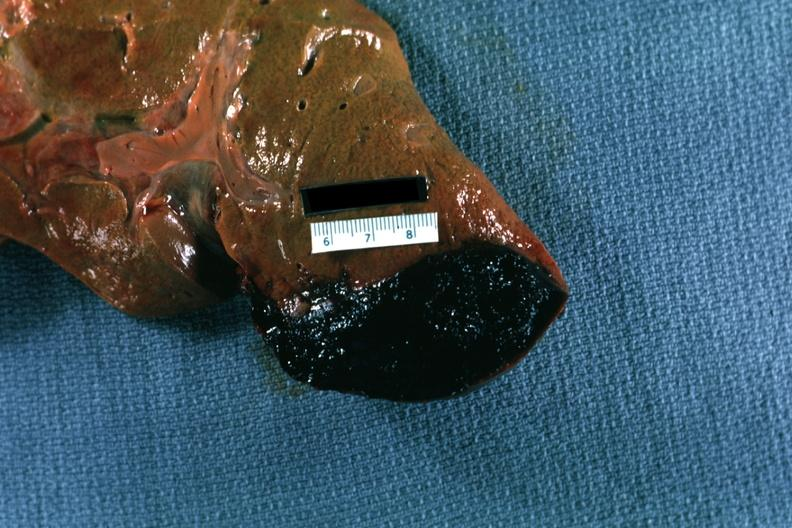does this image show inferior right side cause?
Answer the question using a single word or phrase. Yes 